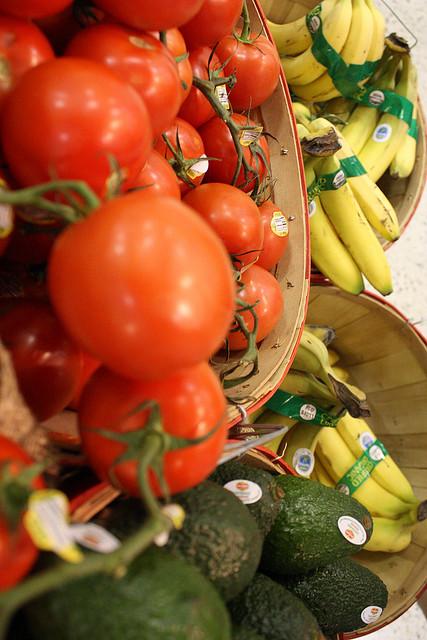Is this a display?
Short answer required. Yes. How many types of fruit are in this photo?
Give a very brief answer. 3. Are these organic tomatoes?
Quick response, please. Yes. 